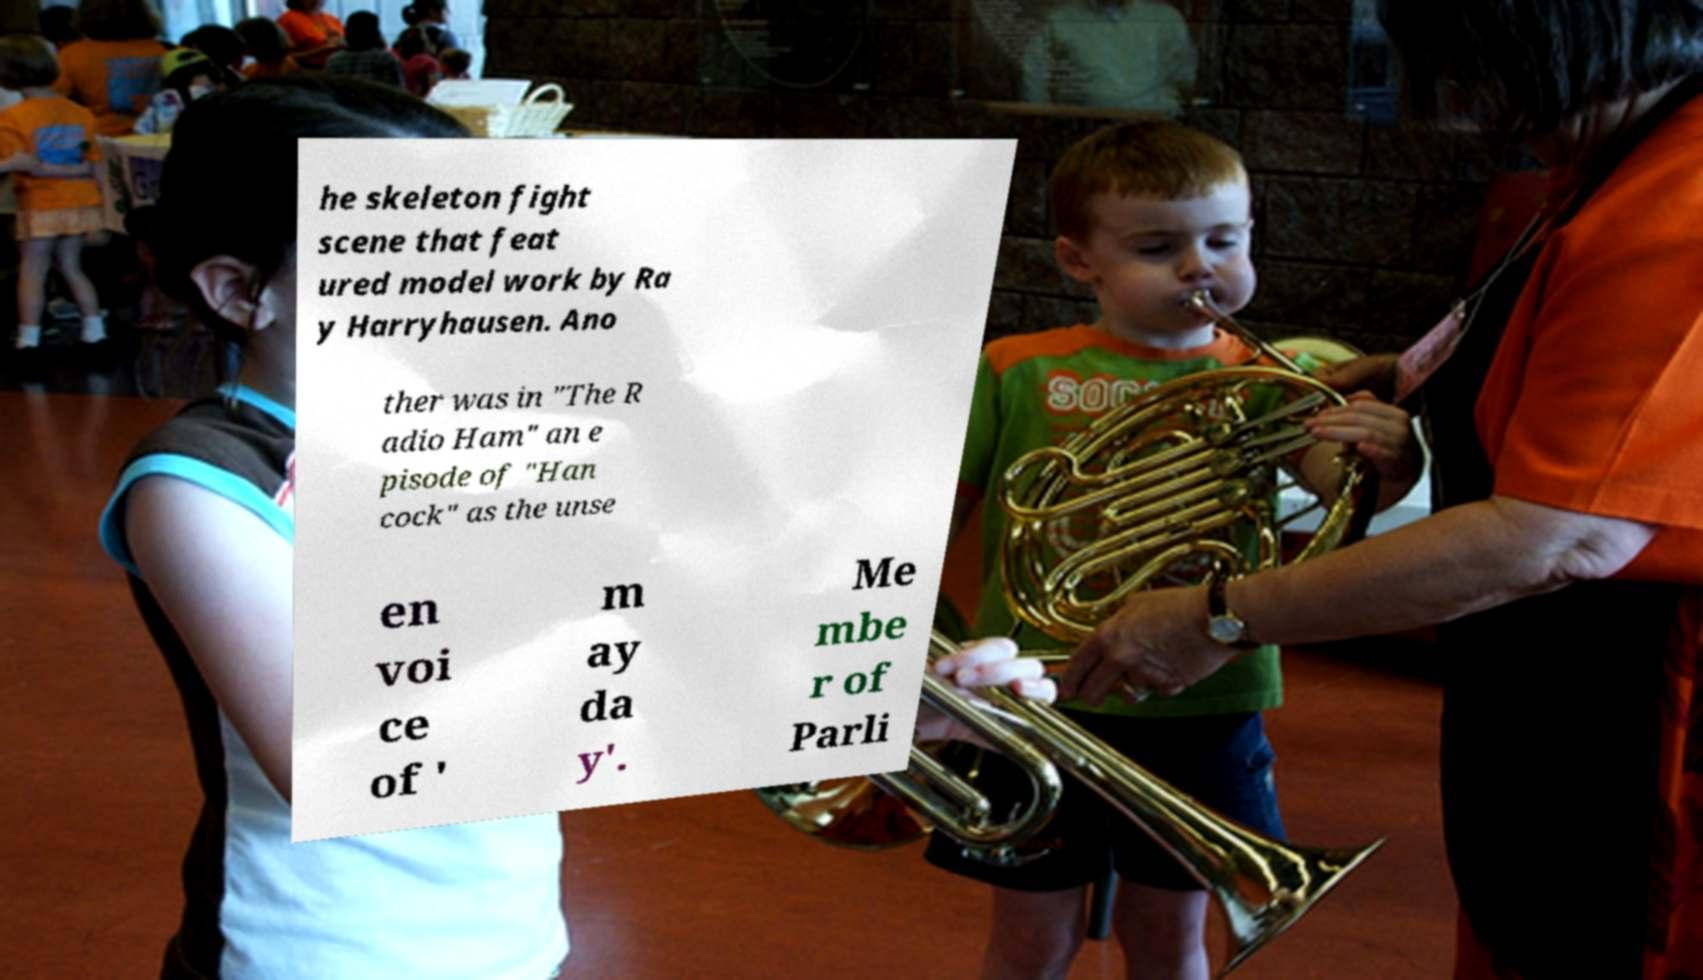Please read and relay the text visible in this image. What does it say? he skeleton fight scene that feat ured model work by Ra y Harryhausen. Ano ther was in "The R adio Ham" an e pisode of "Han cock" as the unse en voi ce of ' m ay da y'. Me mbe r of Parli 